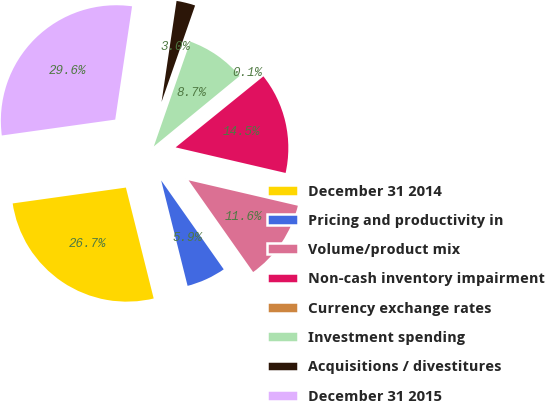Convert chart. <chart><loc_0><loc_0><loc_500><loc_500><pie_chart><fcel>December 31 2014<fcel>Pricing and productivity in<fcel>Volume/product mix<fcel>Non-cash inventory impairment<fcel>Currency exchange rates<fcel>Investment spending<fcel>Acquisitions / divestitures<fcel>December 31 2015<nl><fcel>26.69%<fcel>5.85%<fcel>11.6%<fcel>14.47%<fcel>0.11%<fcel>8.73%<fcel>2.98%<fcel>29.56%<nl></chart> 